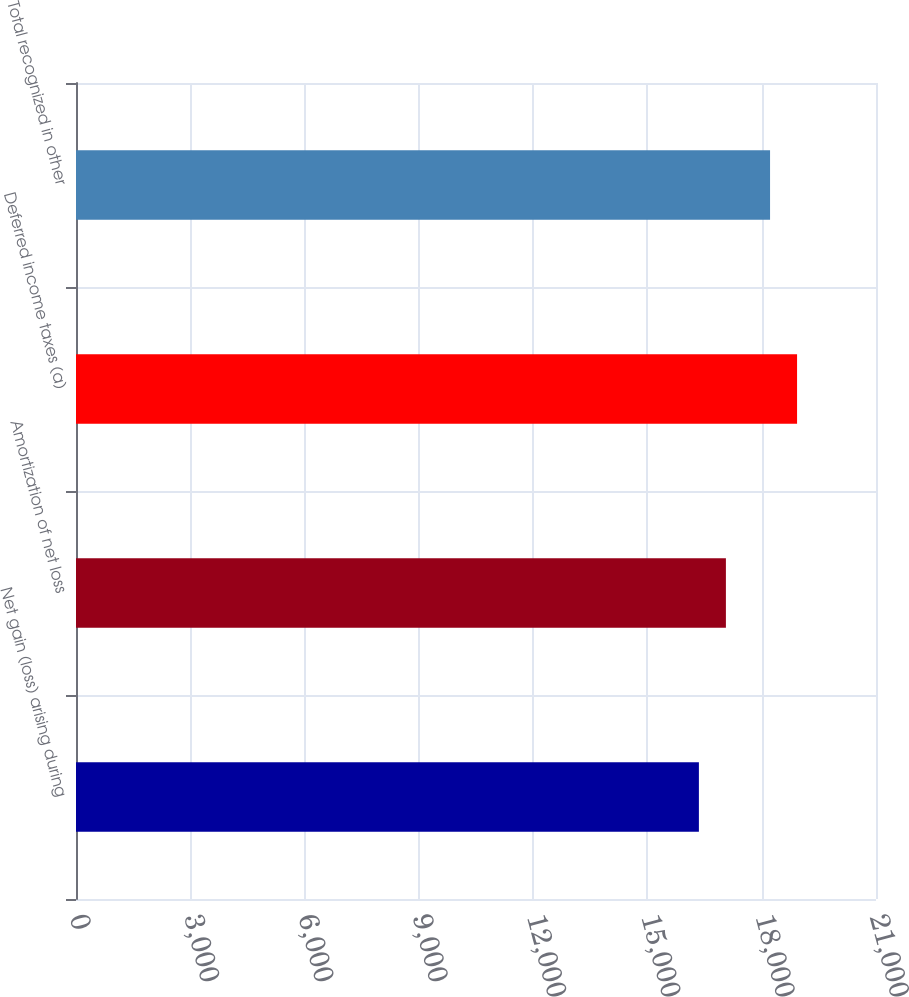Convert chart. <chart><loc_0><loc_0><loc_500><loc_500><bar_chart><fcel>Net gain (loss) arising during<fcel>Amortization of net loss<fcel>Deferred income taxes (a)<fcel>Total recognized in other<nl><fcel>16351<fcel>17060<fcel>18928<fcel>18219<nl></chart> 